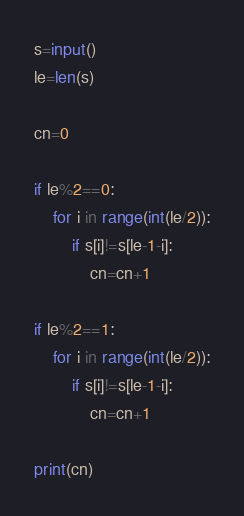Convert code to text. <code><loc_0><loc_0><loc_500><loc_500><_Python_>s=input()
le=len(s)

cn=0

if le%2==0:
    for i in range(int(le/2)):
        if s[i]!=s[le-1-i]:
            cn=cn+1

if le%2==1:
    for i in range(int(le/2)):
        if s[i]!=s[le-1-i]:
            cn=cn+1

print(cn)
</code> 